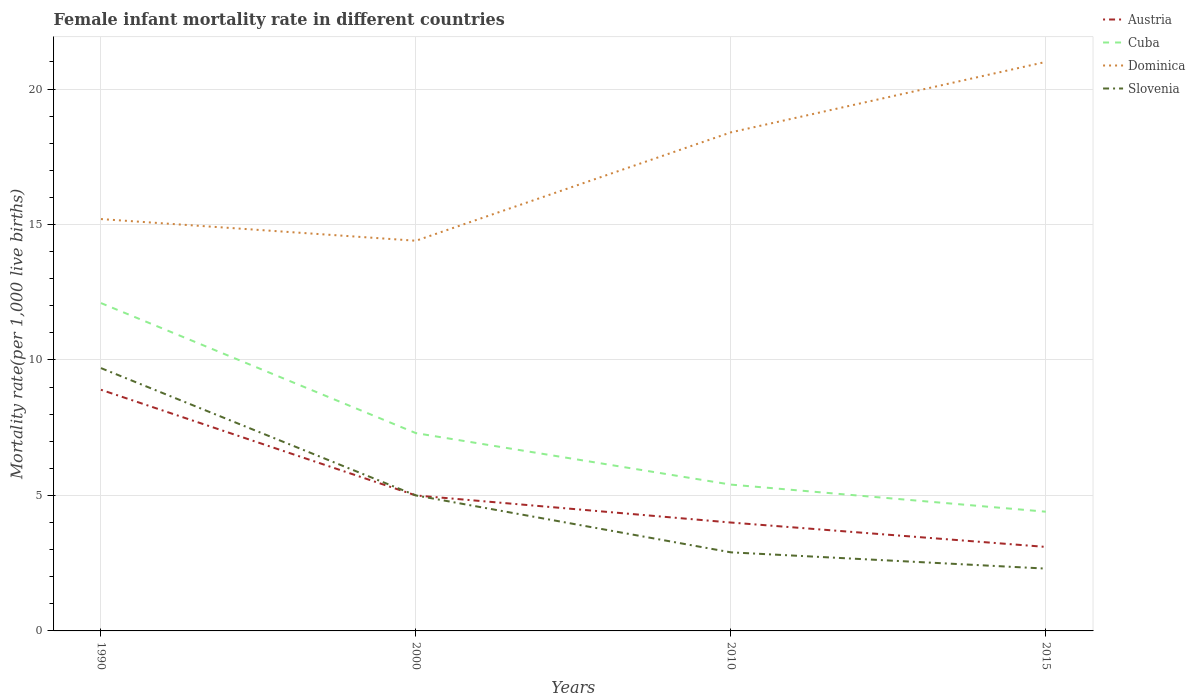How many different coloured lines are there?
Offer a very short reply. 4. Does the line corresponding to Cuba intersect with the line corresponding to Austria?
Your answer should be very brief. No. Is the number of lines equal to the number of legend labels?
Make the answer very short. Yes. What is the total female infant mortality rate in Slovenia in the graph?
Your answer should be very brief. 7.4. What is the difference between the highest and the second highest female infant mortality rate in Slovenia?
Provide a short and direct response. 7.4. What is the difference between the highest and the lowest female infant mortality rate in Cuba?
Your answer should be compact. 2. Is the female infant mortality rate in Dominica strictly greater than the female infant mortality rate in Cuba over the years?
Provide a short and direct response. No. How many years are there in the graph?
Offer a terse response. 4. What is the difference between two consecutive major ticks on the Y-axis?
Your response must be concise. 5. Does the graph contain any zero values?
Offer a very short reply. No. What is the title of the graph?
Provide a short and direct response. Female infant mortality rate in different countries. Does "Croatia" appear as one of the legend labels in the graph?
Keep it short and to the point. No. What is the label or title of the X-axis?
Give a very brief answer. Years. What is the label or title of the Y-axis?
Offer a terse response. Mortality rate(per 1,0 live births). What is the Mortality rate(per 1,000 live births) in Austria in 1990?
Offer a very short reply. 8.9. What is the Mortality rate(per 1,000 live births) in Cuba in 1990?
Ensure brevity in your answer.  12.1. What is the Mortality rate(per 1,000 live births) of Austria in 2000?
Provide a succinct answer. 5. What is the Mortality rate(per 1,000 live births) in Cuba in 2010?
Your response must be concise. 5.4. What is the Mortality rate(per 1,000 live births) of Slovenia in 2010?
Ensure brevity in your answer.  2.9. Across all years, what is the maximum Mortality rate(per 1,000 live births) of Dominica?
Give a very brief answer. 21. Across all years, what is the maximum Mortality rate(per 1,000 live births) in Slovenia?
Give a very brief answer. 9.7. Across all years, what is the minimum Mortality rate(per 1,000 live births) of Austria?
Keep it short and to the point. 3.1. Across all years, what is the minimum Mortality rate(per 1,000 live births) of Cuba?
Your answer should be compact. 4.4. Across all years, what is the minimum Mortality rate(per 1,000 live births) of Slovenia?
Keep it short and to the point. 2.3. What is the total Mortality rate(per 1,000 live births) of Cuba in the graph?
Give a very brief answer. 29.2. What is the total Mortality rate(per 1,000 live births) in Dominica in the graph?
Your answer should be very brief. 69. What is the total Mortality rate(per 1,000 live births) of Slovenia in the graph?
Make the answer very short. 19.9. What is the difference between the Mortality rate(per 1,000 live births) in Austria in 1990 and that in 2000?
Keep it short and to the point. 3.9. What is the difference between the Mortality rate(per 1,000 live births) in Dominica in 1990 and that in 2000?
Your response must be concise. 0.8. What is the difference between the Mortality rate(per 1,000 live births) in Slovenia in 1990 and that in 2000?
Provide a short and direct response. 4.7. What is the difference between the Mortality rate(per 1,000 live births) of Dominica in 1990 and that in 2010?
Provide a succinct answer. -3.2. What is the difference between the Mortality rate(per 1,000 live births) of Dominica in 1990 and that in 2015?
Make the answer very short. -5.8. What is the difference between the Mortality rate(per 1,000 live births) of Slovenia in 1990 and that in 2015?
Offer a terse response. 7.4. What is the difference between the Mortality rate(per 1,000 live births) of Austria in 2000 and that in 2010?
Provide a succinct answer. 1. What is the difference between the Mortality rate(per 1,000 live births) of Dominica in 2000 and that in 2010?
Give a very brief answer. -4. What is the difference between the Mortality rate(per 1,000 live births) of Austria in 2000 and that in 2015?
Offer a terse response. 1.9. What is the difference between the Mortality rate(per 1,000 live births) in Cuba in 2000 and that in 2015?
Provide a short and direct response. 2.9. What is the difference between the Mortality rate(per 1,000 live births) of Slovenia in 2000 and that in 2015?
Provide a short and direct response. 2.7. What is the difference between the Mortality rate(per 1,000 live births) of Austria in 2010 and that in 2015?
Your response must be concise. 0.9. What is the difference between the Mortality rate(per 1,000 live births) of Cuba in 2010 and that in 2015?
Keep it short and to the point. 1. What is the difference between the Mortality rate(per 1,000 live births) of Dominica in 2010 and that in 2015?
Your answer should be very brief. -2.6. What is the difference between the Mortality rate(per 1,000 live births) of Austria in 1990 and the Mortality rate(per 1,000 live births) of Cuba in 2000?
Your answer should be very brief. 1.6. What is the difference between the Mortality rate(per 1,000 live births) of Austria in 1990 and the Mortality rate(per 1,000 live births) of Dominica in 2000?
Your answer should be compact. -5.5. What is the difference between the Mortality rate(per 1,000 live births) in Austria in 1990 and the Mortality rate(per 1,000 live births) in Slovenia in 2000?
Your answer should be very brief. 3.9. What is the difference between the Mortality rate(per 1,000 live births) in Cuba in 1990 and the Mortality rate(per 1,000 live births) in Slovenia in 2000?
Your answer should be very brief. 7.1. What is the difference between the Mortality rate(per 1,000 live births) of Dominica in 1990 and the Mortality rate(per 1,000 live births) of Slovenia in 2000?
Give a very brief answer. 10.2. What is the difference between the Mortality rate(per 1,000 live births) in Cuba in 1990 and the Mortality rate(per 1,000 live births) in Dominica in 2010?
Ensure brevity in your answer.  -6.3. What is the difference between the Mortality rate(per 1,000 live births) in Cuba in 1990 and the Mortality rate(per 1,000 live births) in Slovenia in 2010?
Keep it short and to the point. 9.2. What is the difference between the Mortality rate(per 1,000 live births) of Austria in 1990 and the Mortality rate(per 1,000 live births) of Slovenia in 2015?
Offer a terse response. 6.6. What is the difference between the Mortality rate(per 1,000 live births) of Austria in 2000 and the Mortality rate(per 1,000 live births) of Cuba in 2015?
Keep it short and to the point. 0.6. What is the difference between the Mortality rate(per 1,000 live births) in Austria in 2000 and the Mortality rate(per 1,000 live births) in Slovenia in 2015?
Make the answer very short. 2.7. What is the difference between the Mortality rate(per 1,000 live births) in Cuba in 2000 and the Mortality rate(per 1,000 live births) in Dominica in 2015?
Your answer should be compact. -13.7. What is the difference between the Mortality rate(per 1,000 live births) in Dominica in 2000 and the Mortality rate(per 1,000 live births) in Slovenia in 2015?
Your answer should be very brief. 12.1. What is the difference between the Mortality rate(per 1,000 live births) of Austria in 2010 and the Mortality rate(per 1,000 live births) of Dominica in 2015?
Keep it short and to the point. -17. What is the difference between the Mortality rate(per 1,000 live births) in Cuba in 2010 and the Mortality rate(per 1,000 live births) in Dominica in 2015?
Ensure brevity in your answer.  -15.6. What is the difference between the Mortality rate(per 1,000 live births) in Cuba in 2010 and the Mortality rate(per 1,000 live births) in Slovenia in 2015?
Provide a short and direct response. 3.1. What is the difference between the Mortality rate(per 1,000 live births) of Dominica in 2010 and the Mortality rate(per 1,000 live births) of Slovenia in 2015?
Your response must be concise. 16.1. What is the average Mortality rate(per 1,000 live births) in Austria per year?
Provide a short and direct response. 5.25. What is the average Mortality rate(per 1,000 live births) of Dominica per year?
Provide a succinct answer. 17.25. What is the average Mortality rate(per 1,000 live births) in Slovenia per year?
Keep it short and to the point. 4.97. In the year 1990, what is the difference between the Mortality rate(per 1,000 live births) of Austria and Mortality rate(per 1,000 live births) of Dominica?
Offer a very short reply. -6.3. In the year 1990, what is the difference between the Mortality rate(per 1,000 live births) of Austria and Mortality rate(per 1,000 live births) of Slovenia?
Ensure brevity in your answer.  -0.8. In the year 1990, what is the difference between the Mortality rate(per 1,000 live births) of Cuba and Mortality rate(per 1,000 live births) of Slovenia?
Offer a terse response. 2.4. In the year 1990, what is the difference between the Mortality rate(per 1,000 live births) of Dominica and Mortality rate(per 1,000 live births) of Slovenia?
Your answer should be very brief. 5.5. In the year 2000, what is the difference between the Mortality rate(per 1,000 live births) in Austria and Mortality rate(per 1,000 live births) in Cuba?
Make the answer very short. -2.3. In the year 2000, what is the difference between the Mortality rate(per 1,000 live births) in Austria and Mortality rate(per 1,000 live births) in Dominica?
Offer a terse response. -9.4. In the year 2000, what is the difference between the Mortality rate(per 1,000 live births) in Cuba and Mortality rate(per 1,000 live births) in Dominica?
Offer a terse response. -7.1. In the year 2000, what is the difference between the Mortality rate(per 1,000 live births) in Cuba and Mortality rate(per 1,000 live births) in Slovenia?
Provide a succinct answer. 2.3. In the year 2000, what is the difference between the Mortality rate(per 1,000 live births) of Dominica and Mortality rate(per 1,000 live births) of Slovenia?
Ensure brevity in your answer.  9.4. In the year 2010, what is the difference between the Mortality rate(per 1,000 live births) of Austria and Mortality rate(per 1,000 live births) of Dominica?
Keep it short and to the point. -14.4. In the year 2010, what is the difference between the Mortality rate(per 1,000 live births) in Austria and Mortality rate(per 1,000 live births) in Slovenia?
Your answer should be very brief. 1.1. In the year 2010, what is the difference between the Mortality rate(per 1,000 live births) of Cuba and Mortality rate(per 1,000 live births) of Slovenia?
Ensure brevity in your answer.  2.5. In the year 2010, what is the difference between the Mortality rate(per 1,000 live births) of Dominica and Mortality rate(per 1,000 live births) of Slovenia?
Give a very brief answer. 15.5. In the year 2015, what is the difference between the Mortality rate(per 1,000 live births) in Austria and Mortality rate(per 1,000 live births) in Cuba?
Offer a very short reply. -1.3. In the year 2015, what is the difference between the Mortality rate(per 1,000 live births) in Austria and Mortality rate(per 1,000 live births) in Dominica?
Provide a succinct answer. -17.9. In the year 2015, what is the difference between the Mortality rate(per 1,000 live births) in Austria and Mortality rate(per 1,000 live births) in Slovenia?
Your answer should be compact. 0.8. In the year 2015, what is the difference between the Mortality rate(per 1,000 live births) in Cuba and Mortality rate(per 1,000 live births) in Dominica?
Your response must be concise. -16.6. In the year 2015, what is the difference between the Mortality rate(per 1,000 live births) in Dominica and Mortality rate(per 1,000 live births) in Slovenia?
Give a very brief answer. 18.7. What is the ratio of the Mortality rate(per 1,000 live births) of Austria in 1990 to that in 2000?
Keep it short and to the point. 1.78. What is the ratio of the Mortality rate(per 1,000 live births) in Cuba in 1990 to that in 2000?
Provide a short and direct response. 1.66. What is the ratio of the Mortality rate(per 1,000 live births) of Dominica in 1990 to that in 2000?
Your response must be concise. 1.06. What is the ratio of the Mortality rate(per 1,000 live births) of Slovenia in 1990 to that in 2000?
Make the answer very short. 1.94. What is the ratio of the Mortality rate(per 1,000 live births) in Austria in 1990 to that in 2010?
Provide a succinct answer. 2.23. What is the ratio of the Mortality rate(per 1,000 live births) of Cuba in 1990 to that in 2010?
Keep it short and to the point. 2.24. What is the ratio of the Mortality rate(per 1,000 live births) in Dominica in 1990 to that in 2010?
Give a very brief answer. 0.83. What is the ratio of the Mortality rate(per 1,000 live births) of Slovenia in 1990 to that in 2010?
Give a very brief answer. 3.34. What is the ratio of the Mortality rate(per 1,000 live births) of Austria in 1990 to that in 2015?
Give a very brief answer. 2.87. What is the ratio of the Mortality rate(per 1,000 live births) in Cuba in 1990 to that in 2015?
Provide a short and direct response. 2.75. What is the ratio of the Mortality rate(per 1,000 live births) in Dominica in 1990 to that in 2015?
Ensure brevity in your answer.  0.72. What is the ratio of the Mortality rate(per 1,000 live births) in Slovenia in 1990 to that in 2015?
Provide a succinct answer. 4.22. What is the ratio of the Mortality rate(per 1,000 live births) in Austria in 2000 to that in 2010?
Keep it short and to the point. 1.25. What is the ratio of the Mortality rate(per 1,000 live births) of Cuba in 2000 to that in 2010?
Your answer should be compact. 1.35. What is the ratio of the Mortality rate(per 1,000 live births) in Dominica in 2000 to that in 2010?
Provide a short and direct response. 0.78. What is the ratio of the Mortality rate(per 1,000 live births) in Slovenia in 2000 to that in 2010?
Your answer should be very brief. 1.72. What is the ratio of the Mortality rate(per 1,000 live births) of Austria in 2000 to that in 2015?
Provide a short and direct response. 1.61. What is the ratio of the Mortality rate(per 1,000 live births) in Cuba in 2000 to that in 2015?
Keep it short and to the point. 1.66. What is the ratio of the Mortality rate(per 1,000 live births) in Dominica in 2000 to that in 2015?
Give a very brief answer. 0.69. What is the ratio of the Mortality rate(per 1,000 live births) of Slovenia in 2000 to that in 2015?
Provide a short and direct response. 2.17. What is the ratio of the Mortality rate(per 1,000 live births) in Austria in 2010 to that in 2015?
Offer a very short reply. 1.29. What is the ratio of the Mortality rate(per 1,000 live births) of Cuba in 2010 to that in 2015?
Provide a succinct answer. 1.23. What is the ratio of the Mortality rate(per 1,000 live births) in Dominica in 2010 to that in 2015?
Offer a very short reply. 0.88. What is the ratio of the Mortality rate(per 1,000 live births) of Slovenia in 2010 to that in 2015?
Make the answer very short. 1.26. What is the difference between the highest and the second highest Mortality rate(per 1,000 live births) of Cuba?
Offer a terse response. 4.8. What is the difference between the highest and the second highest Mortality rate(per 1,000 live births) of Dominica?
Your answer should be compact. 2.6. What is the difference between the highest and the lowest Mortality rate(per 1,000 live births) in Austria?
Make the answer very short. 5.8. What is the difference between the highest and the lowest Mortality rate(per 1,000 live births) in Cuba?
Your answer should be compact. 7.7. 